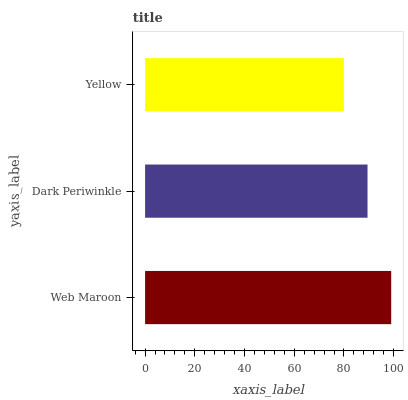Is Yellow the minimum?
Answer yes or no. Yes. Is Web Maroon the maximum?
Answer yes or no. Yes. Is Dark Periwinkle the minimum?
Answer yes or no. No. Is Dark Periwinkle the maximum?
Answer yes or no. No. Is Web Maroon greater than Dark Periwinkle?
Answer yes or no. Yes. Is Dark Periwinkle less than Web Maroon?
Answer yes or no. Yes. Is Dark Periwinkle greater than Web Maroon?
Answer yes or no. No. Is Web Maroon less than Dark Periwinkle?
Answer yes or no. No. Is Dark Periwinkle the high median?
Answer yes or no. Yes. Is Dark Periwinkle the low median?
Answer yes or no. Yes. Is Web Maroon the high median?
Answer yes or no. No. Is Yellow the low median?
Answer yes or no. No. 